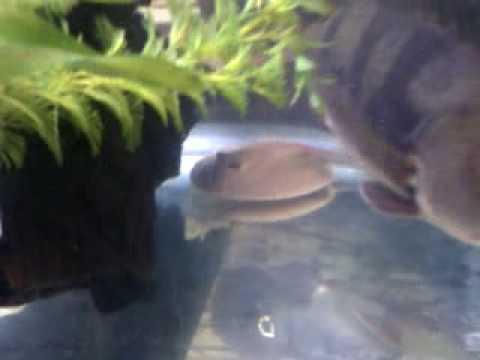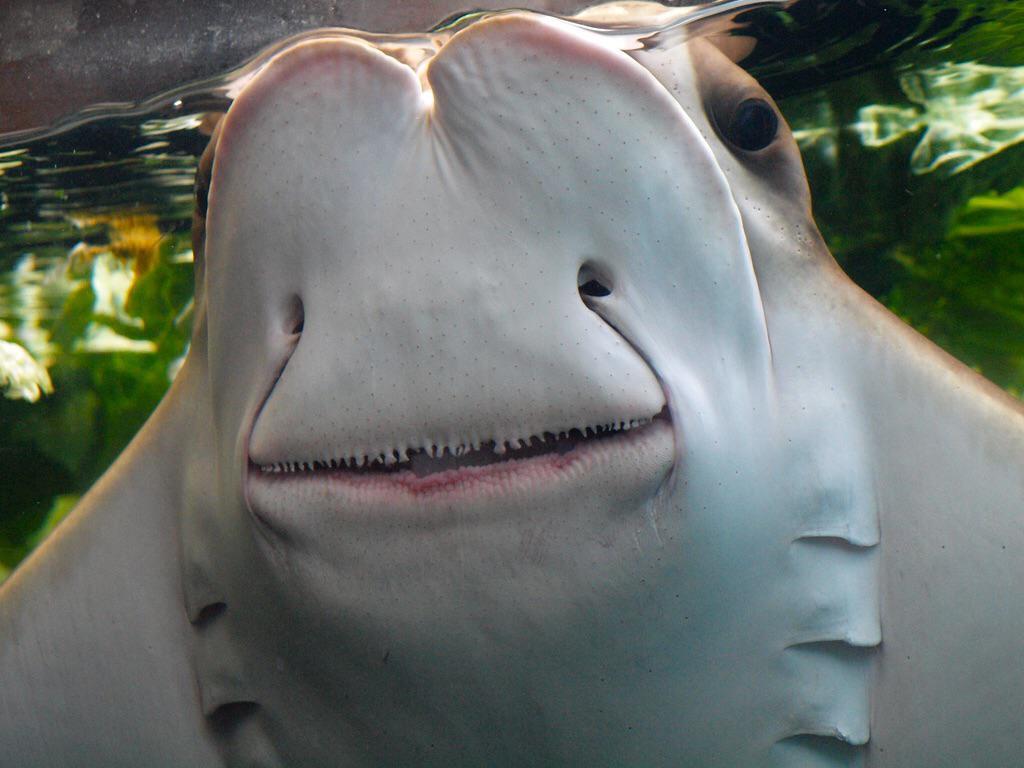The first image is the image on the left, the second image is the image on the right. Analyze the images presented: Is the assertion "In one of the images, a human hand is interacting with a fish." valid? Answer yes or no. No. The first image is the image on the left, the second image is the image on the right. Evaluate the accuracy of this statement regarding the images: "A person is hand feeding a marine animal.". Is it true? Answer yes or no. No. 